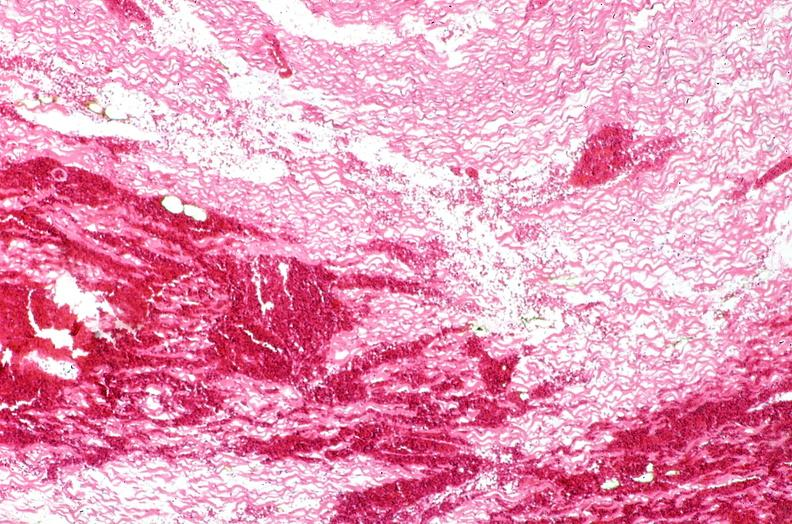what does this image show?
Answer the question using a single word or phrase. Heart 